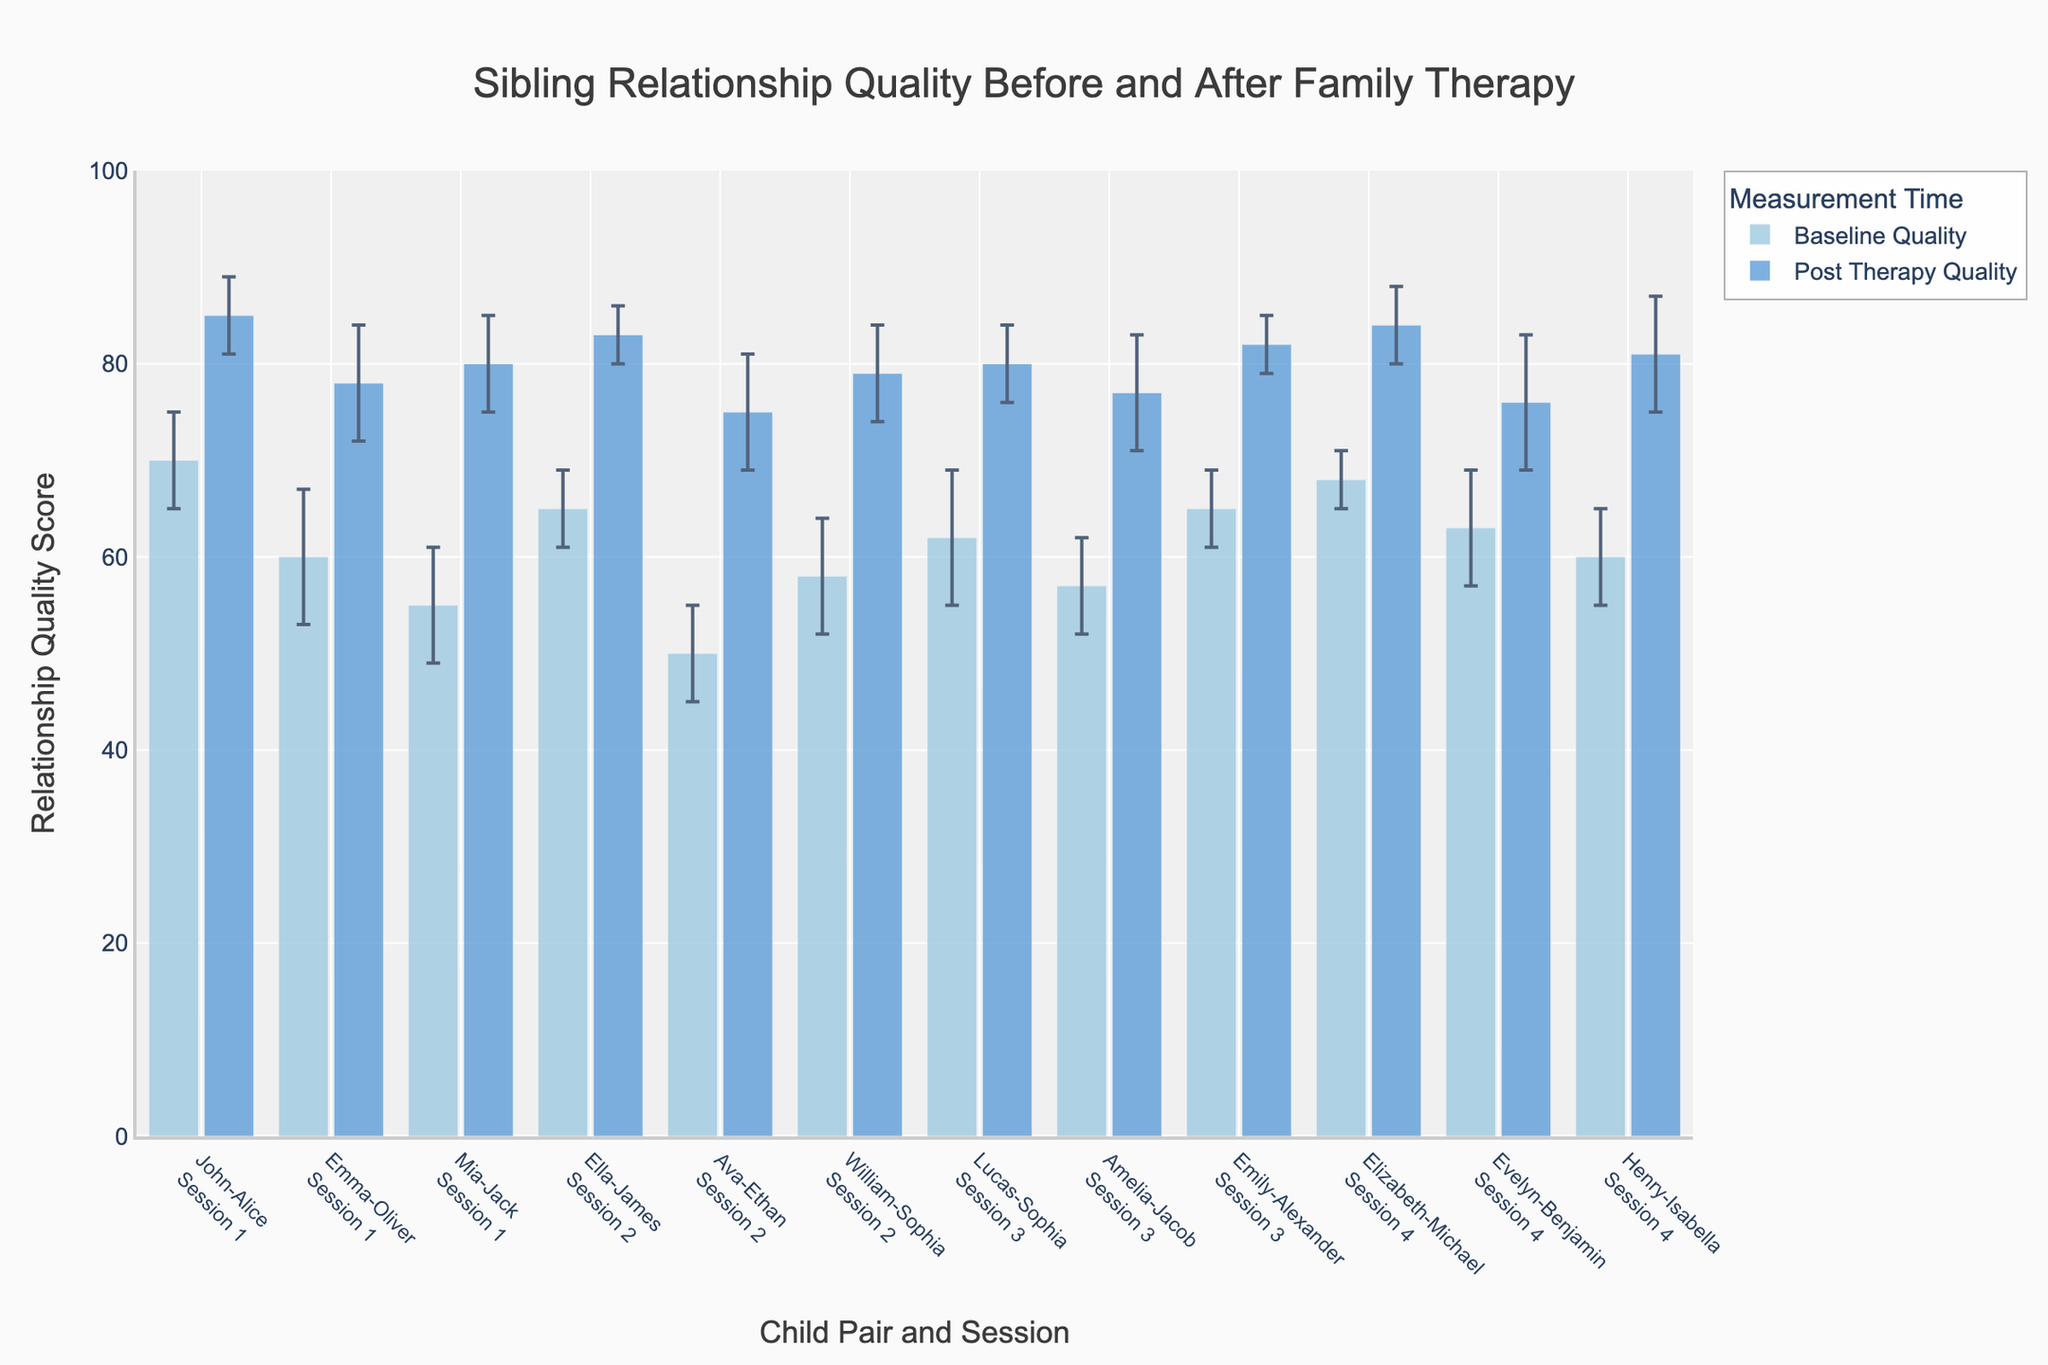what is the title of the figure? The title of the figure is usually displayed at the top, and in this case, it reads 'Sibling Relationship Quality Before and After Family Therapy'.
Answer: Sibling Relationship Quality Before and After Family Therapy What is the x-axis label in the plot? The x-axis label provides information about what data is depicted along the horizontal axis. The label is 'Child Pair and Session'.
Answer: Child Pair and Session What is the range of the y-axis? The y-axis represents the relationship quality scores. From the plot, the range is visible and it goes from 0 to 100.
Answer: 0 to 100 How many child pairs were assessed in the therapy sessions? Each bar represents a child pair under specific sessions. By counting all the pairs shown on the x-axis, we can see there are a total of 12 child pairs.
Answer: 12 Which child pair had the highest post-therapy quality score in Session 1? By comparing the heights of the bars corresponding to post-therapy quality scores for session 1, the highest bar belongs to the 'Mia-Jack' pair.
Answer: Mia-Jack Which child pair had the largest improvement in relationship quality after therapy? The improvement can be calculated by subtracting the baseline quality score from the post-therapy quality score for each pair. 'Mia-Jack' shows the largest improvement from 55 to 80.
Answer: Mia-Jack What are the standard deviation values for 'Ella-James' before and after therapy in Session 2? The error bars represent the standard deviation. For 'Ella-James', the standard deviation before therapy is 4 and after therapy, it is 3.
Answer: 4 and 3 Are the standard deviations generally higher before or after therapy? By observing the lengths of error bars, it is noticeable that the standard deviations are generally higher before therapy compared to post-therapy.
Answer: Before therapy What is the average post-therapy quality score for all the child pairs in the plot? Summing all the post-therapy scores (85+78+80+83+75+79+80+77+82+84+76+81 = 960) and dividing by the number of pairs (12) gives the average post-therapy quality score.
Answer: 80 Which session had the highest overall improvement in relationship quality scores? Calculate the total difference in scores for each child pair in each session and compare them. Session 1: (15 + 18 + 25), Session 2: (18 + 25 + 21), Session 3: (18 + 20 + 17), Session 4: (16 + 13 + 21). Session 2 has the highest overall improvement with a total of 64.
Answer: Session 2 